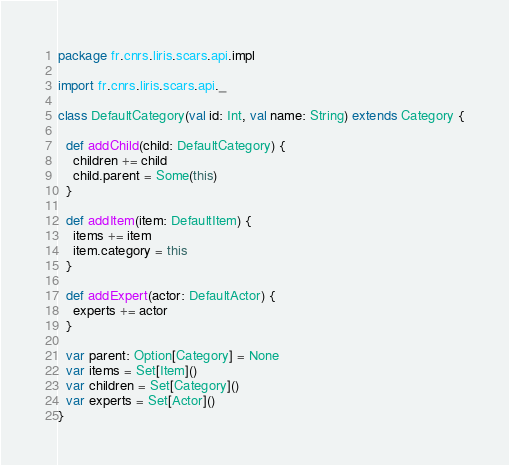Convert code to text. <code><loc_0><loc_0><loc_500><loc_500><_Scala_>package fr.cnrs.liris.scars.api.impl

import fr.cnrs.liris.scars.api._

class DefaultCategory(val id: Int, val name: String) extends Category {
  
  def addChild(child: DefaultCategory) {
    children += child
    child.parent = Some(this)
  }
  
  def addItem(item: DefaultItem) {
    items += item
    item.category = this
  }
  
  def addExpert(actor: DefaultActor) {
    experts += actor
  }
  
  var parent: Option[Category] = None
  var items = Set[Item]()
  var children = Set[Category]()
  var experts = Set[Actor]()
}</code> 